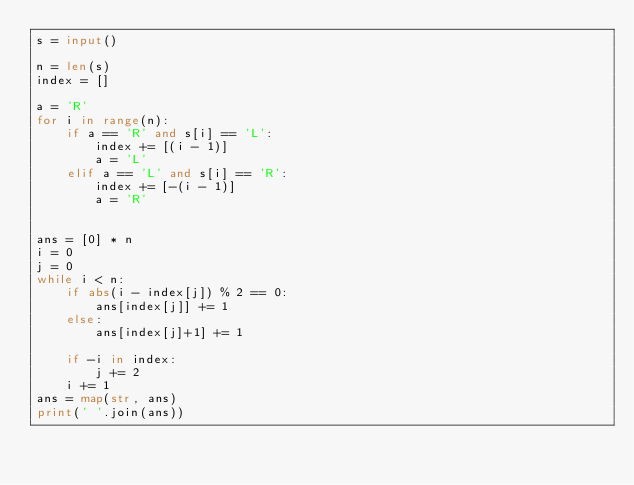<code> <loc_0><loc_0><loc_500><loc_500><_Python_>s = input()

n = len(s)
index = []

a = 'R'
for i in range(n):
    if a == 'R' and s[i] == 'L':
        index += [(i - 1)]
        a = 'L'
    elif a == 'L' and s[i] == 'R':
        index += [-(i - 1)]
        a = 'R'


ans = [0] * n
i = 0
j = 0
while i < n:
    if abs(i - index[j]) % 2 == 0:
        ans[index[j]] += 1
    else:
        ans[index[j]+1] += 1

    if -i in index:
        j += 2
    i += 1
ans = map(str, ans)
print(' '.join(ans))</code> 